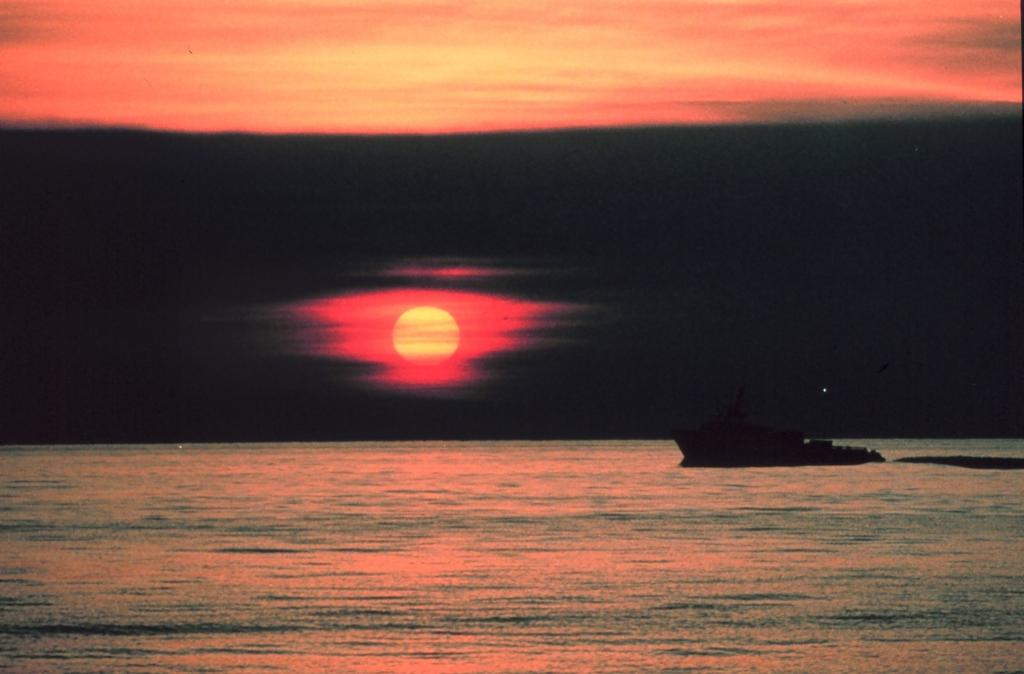What is the main subject of the image? The main subject of the image is a ship. Where is the ship located? The ship is on the ocean. What can be seen in the sky in the image? The sun and sky are visible in the image. What type of guitar is being played on the ship in the image? There is no guitar present in the image; it only features a ship on the ocean. 